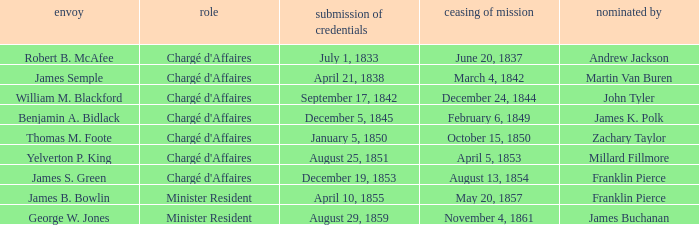What Representative has a Presentation of Credentails of April 10, 1855? James B. Bowlin. 